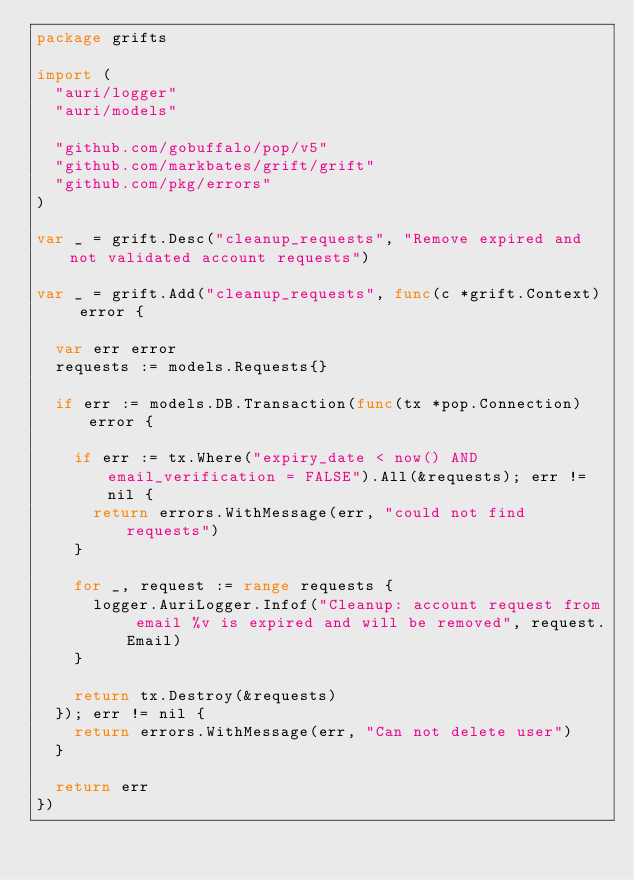Convert code to text. <code><loc_0><loc_0><loc_500><loc_500><_Go_>package grifts

import (
	"auri/logger"
	"auri/models"

	"github.com/gobuffalo/pop/v5"
	"github.com/markbates/grift/grift"
	"github.com/pkg/errors"
)

var _ = grift.Desc("cleanup_requests", "Remove expired and not validated account requests")

var _ = grift.Add("cleanup_requests", func(c *grift.Context) error {

	var err error
	requests := models.Requests{}

	if err := models.DB.Transaction(func(tx *pop.Connection) error {

		if err := tx.Where("expiry_date < now() AND email_verification = FALSE").All(&requests); err != nil {
			return errors.WithMessage(err, "could not find requests")
		}

		for _, request := range requests {
			logger.AuriLogger.Infof("Cleanup: account request from email %v is expired and will be removed", request.Email)
		}

		return tx.Destroy(&requests)
	}); err != nil {
		return errors.WithMessage(err, "Can not delete user")
	}

	return err
})
</code> 